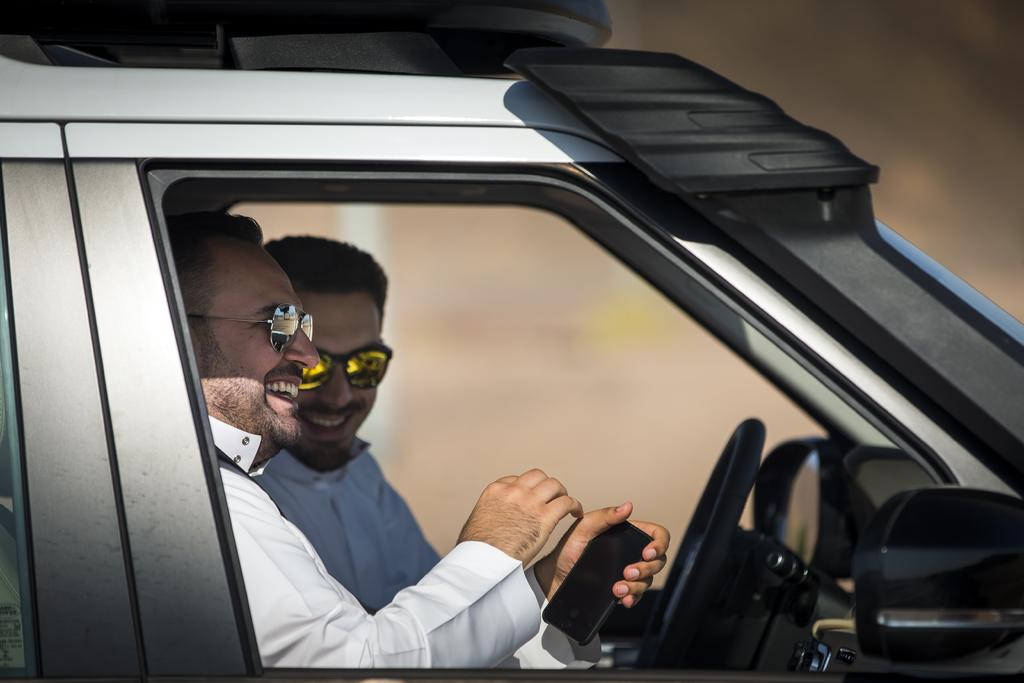How many people are in the image? There are two people in the image. What are the people doing in the image? The two people are sitting inside a car. What expressions do the people have in the image? The people are smiling in the image. What are the people wearing in the image? They are wearing white clothes and sunglasses. What is the person in the front holding in the image? The person in the front is holding a mobile phone. What is the argument about in the image? There is no argument present in the image; the people are smiling and appear to be enjoying themselves. What type of trail can be seen in the image? There is no trail visible in the image; it features two people sitting inside a car. 